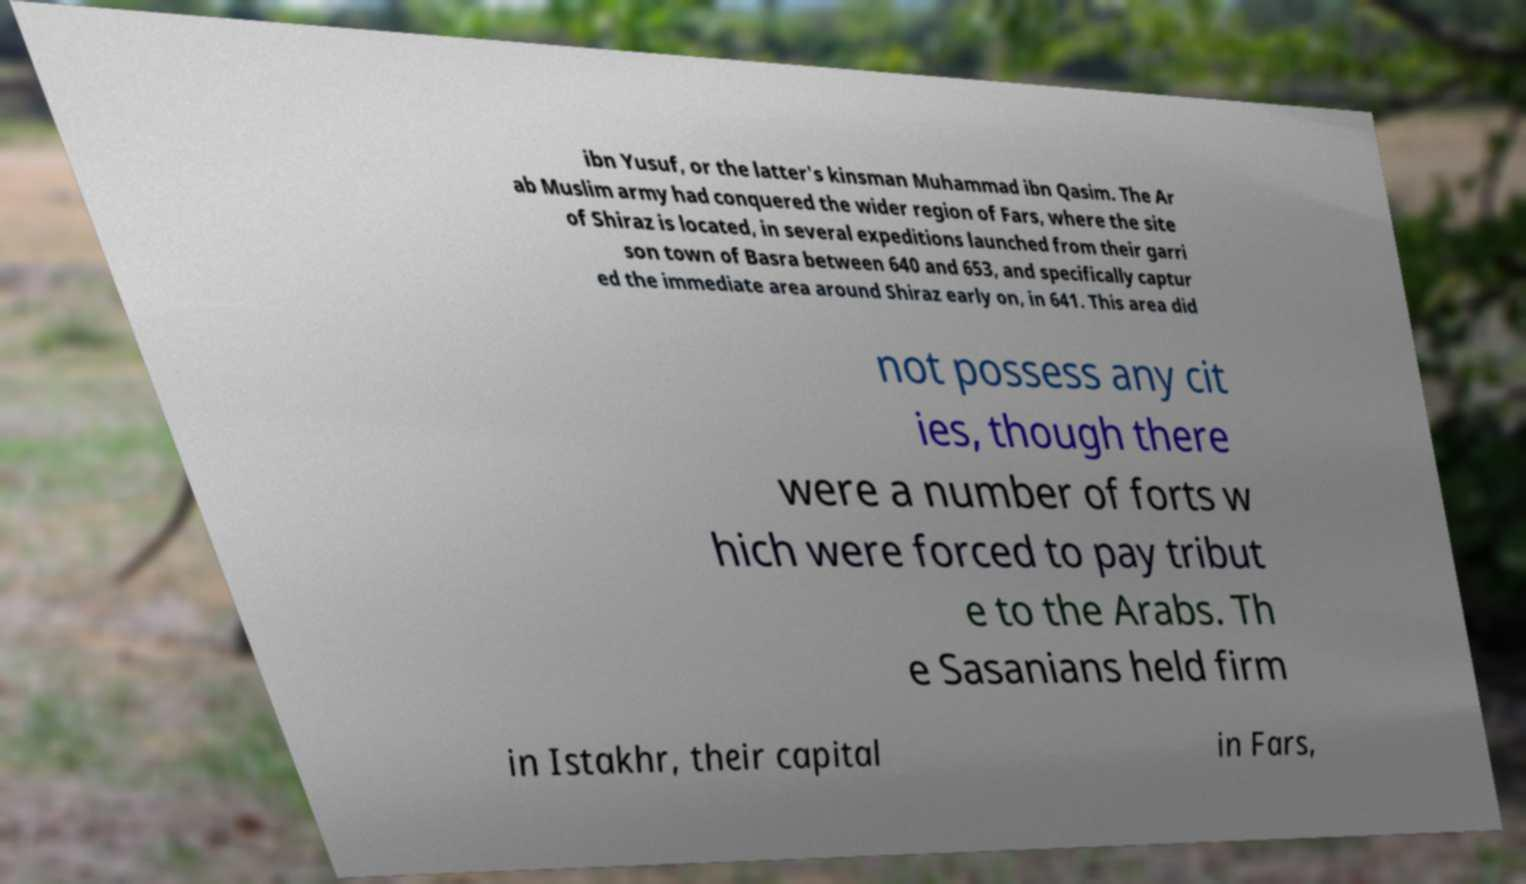Please identify and transcribe the text found in this image. ibn Yusuf, or the latter's kinsman Muhammad ibn Qasim. The Ar ab Muslim army had conquered the wider region of Fars, where the site of Shiraz is located, in several expeditions launched from their garri son town of Basra between 640 and 653, and specifically captur ed the immediate area around Shiraz early on, in 641. This area did not possess any cit ies, though there were a number of forts w hich were forced to pay tribut e to the Arabs. Th e Sasanians held firm in Istakhr, their capital in Fars, 